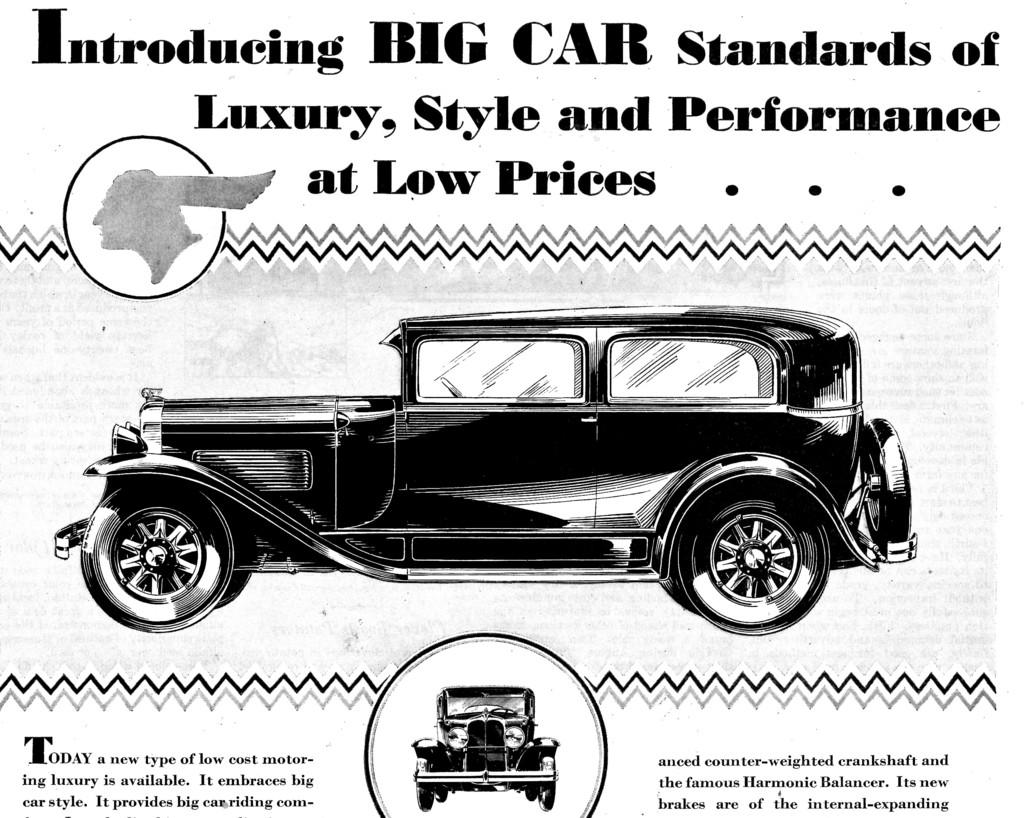What is featured on the poster in the image? There is a poster in the image, and it contains a picture of a car. What else can be seen on the poster besides the picture of the car? There is text on the poster. How many brothers are depicted in the poster? There are no brothers depicted in the poster; it features a picture of a car and text. What degree does the person in the poster hold? There is no person present in the poster, and therefore no degree can be attributed to anyone. 